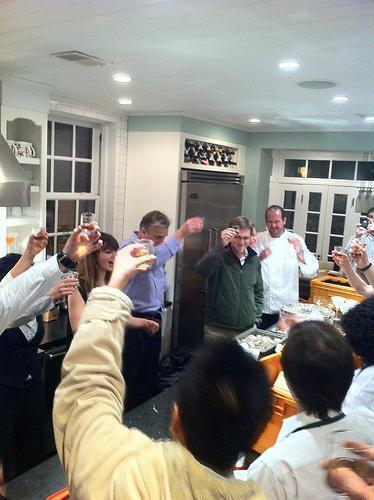How many refrigerators are there?
Give a very brief answer. 1. 